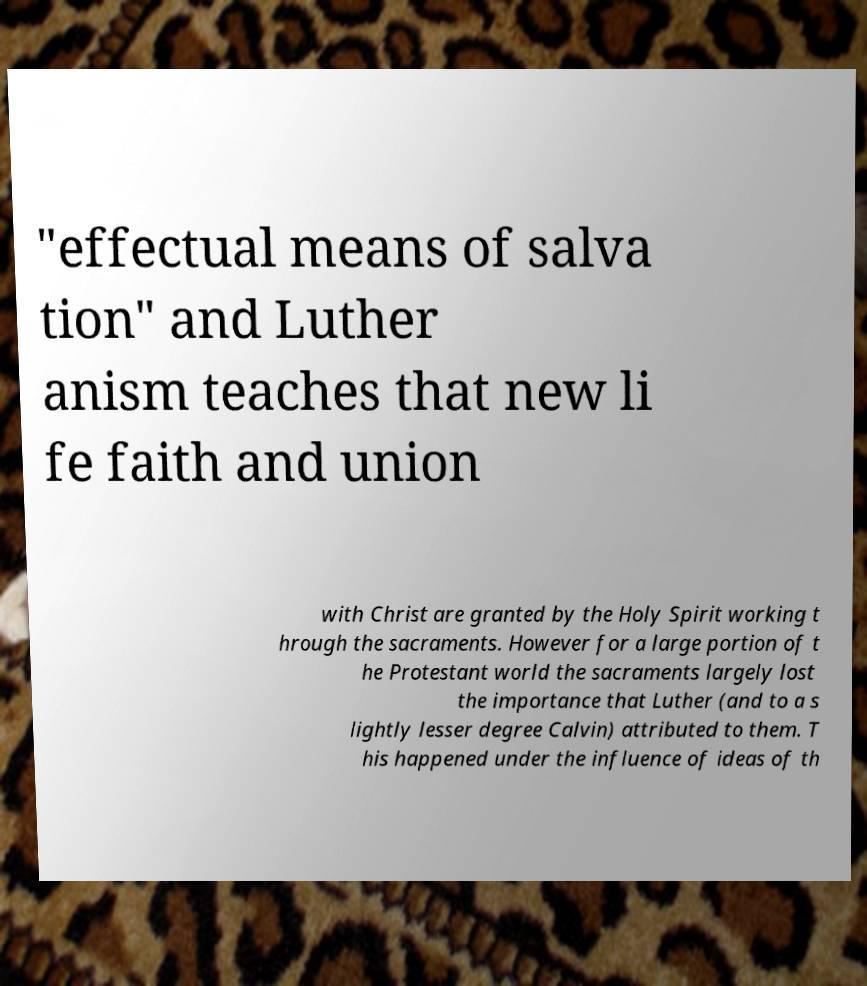I need the written content from this picture converted into text. Can you do that? "effectual means of salva tion" and Luther anism teaches that new li fe faith and union with Christ are granted by the Holy Spirit working t hrough the sacraments. However for a large portion of t he Protestant world the sacraments largely lost the importance that Luther (and to a s lightly lesser degree Calvin) attributed to them. T his happened under the influence of ideas of th 